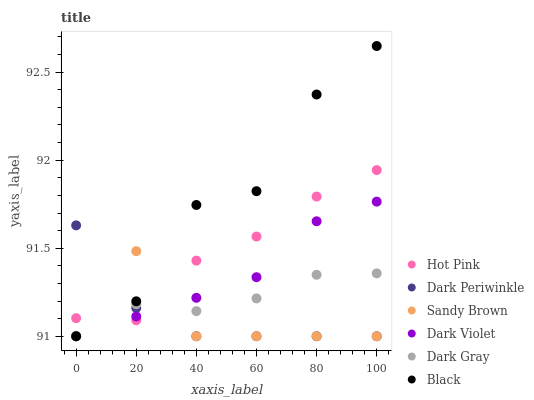Does Dark Periwinkle have the minimum area under the curve?
Answer yes or no. Yes. Does Black have the maximum area under the curve?
Answer yes or no. Yes. Does Dark Violet have the minimum area under the curve?
Answer yes or no. No. Does Dark Violet have the maximum area under the curve?
Answer yes or no. No. Is Dark Violet the smoothest?
Answer yes or no. Yes. Is Black the roughest?
Answer yes or no. Yes. Is Dark Gray the smoothest?
Answer yes or no. No. Is Dark Gray the roughest?
Answer yes or no. No. Does Dark Violet have the lowest value?
Answer yes or no. Yes. Does Black have the highest value?
Answer yes or no. Yes. Does Dark Violet have the highest value?
Answer yes or no. No. Does Dark Gray intersect Dark Periwinkle?
Answer yes or no. Yes. Is Dark Gray less than Dark Periwinkle?
Answer yes or no. No. Is Dark Gray greater than Dark Periwinkle?
Answer yes or no. No. 